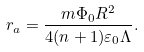Convert formula to latex. <formula><loc_0><loc_0><loc_500><loc_500>r _ { a } = \frac { m \Phi _ { 0 } R ^ { 2 } } { 4 ( n + 1 ) \varepsilon _ { 0 } \Lambda } .</formula> 